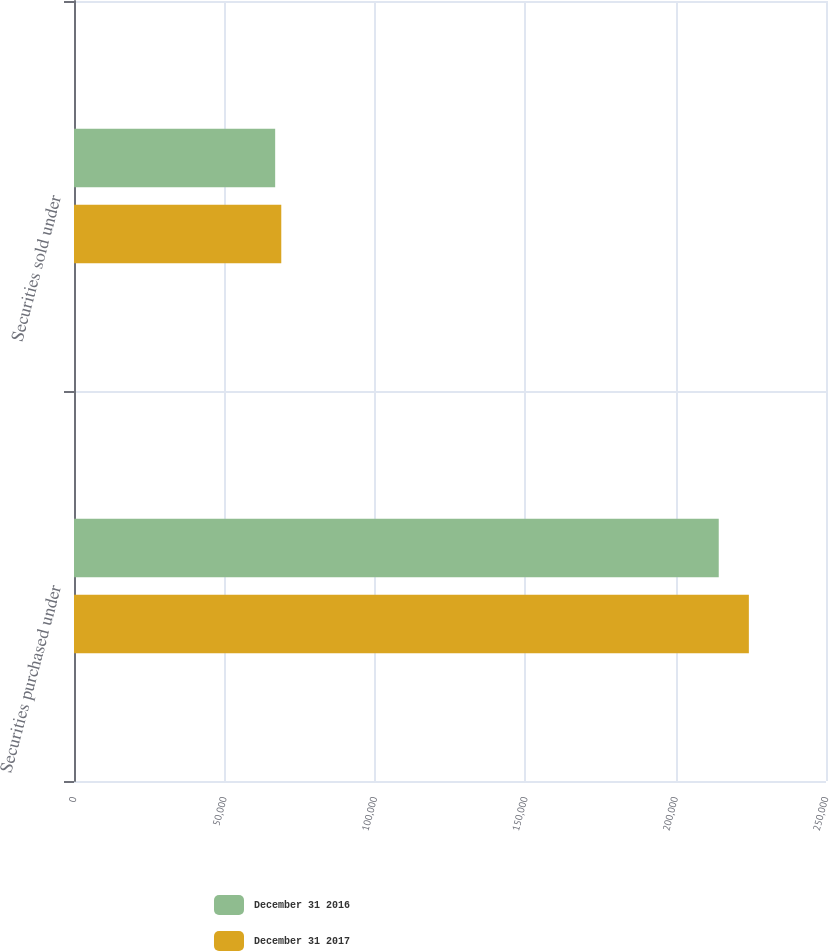<chart> <loc_0><loc_0><loc_500><loc_500><stacked_bar_chart><ecel><fcel>Securities purchased under<fcel>Securities sold under<nl><fcel>December 31 2016<fcel>214343<fcel>66879<nl><fcel>December 31 2017<fcel>224355<fcel>68908<nl></chart> 